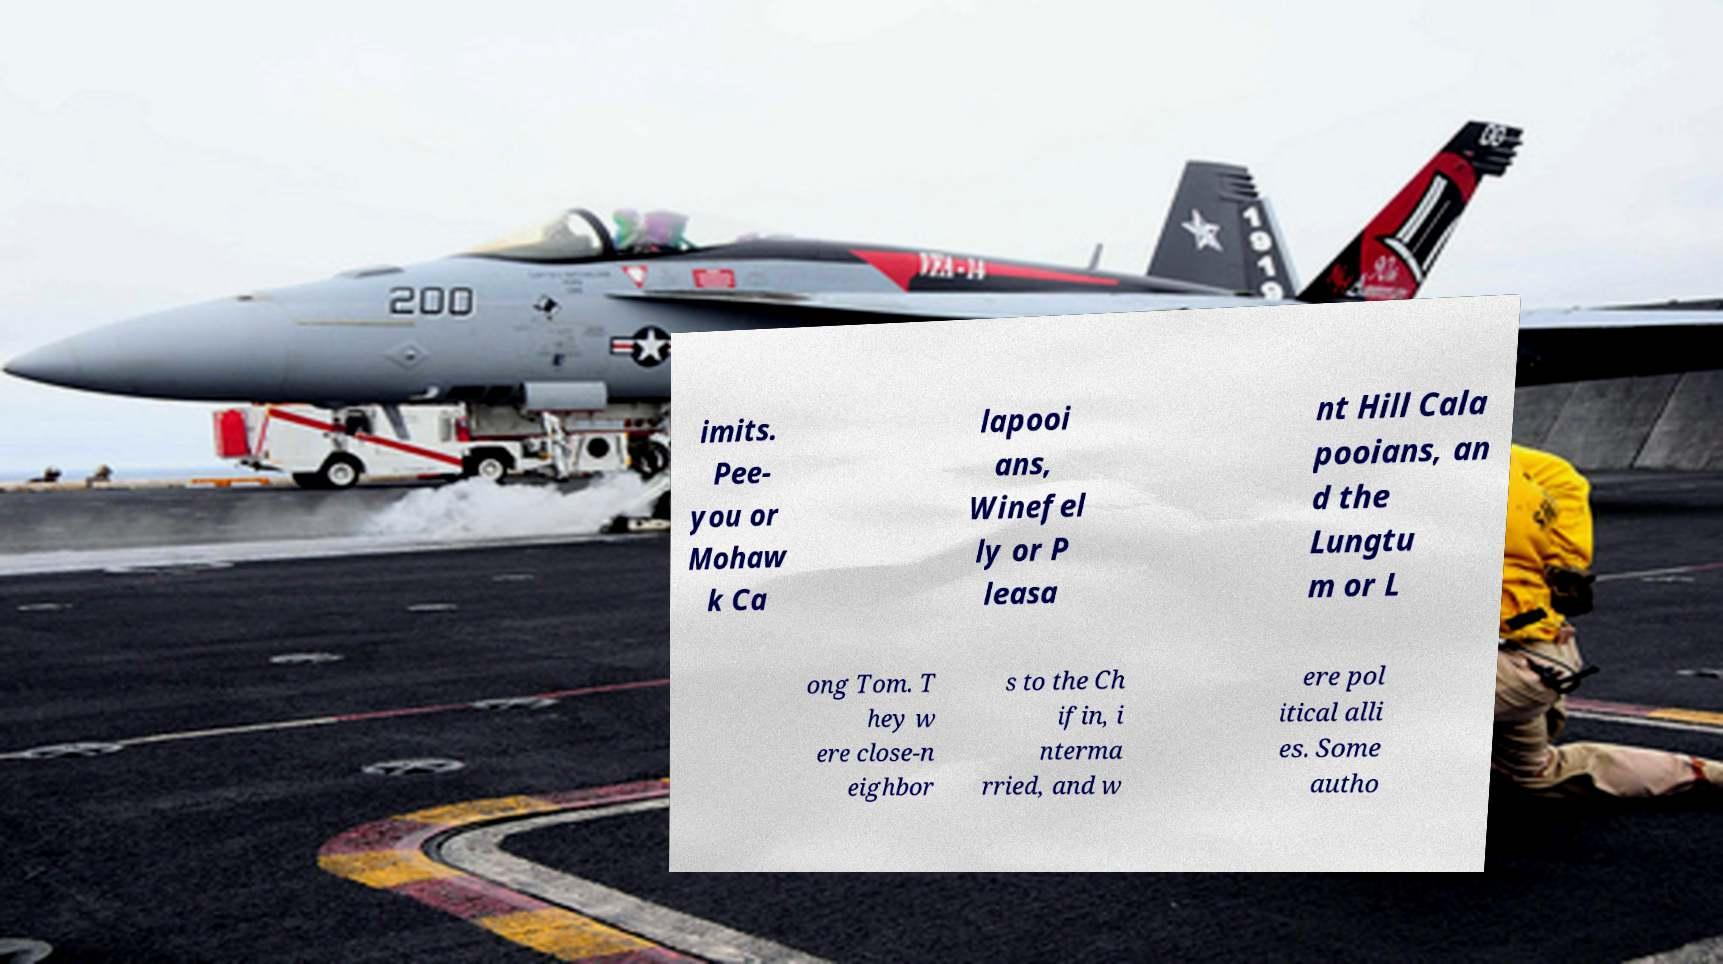Please read and relay the text visible in this image. What does it say? imits. Pee- you or Mohaw k Ca lapooi ans, Winefel ly or P leasa nt Hill Cala pooians, an d the Lungtu m or L ong Tom. T hey w ere close-n eighbor s to the Ch ifin, i nterma rried, and w ere pol itical alli es. Some autho 